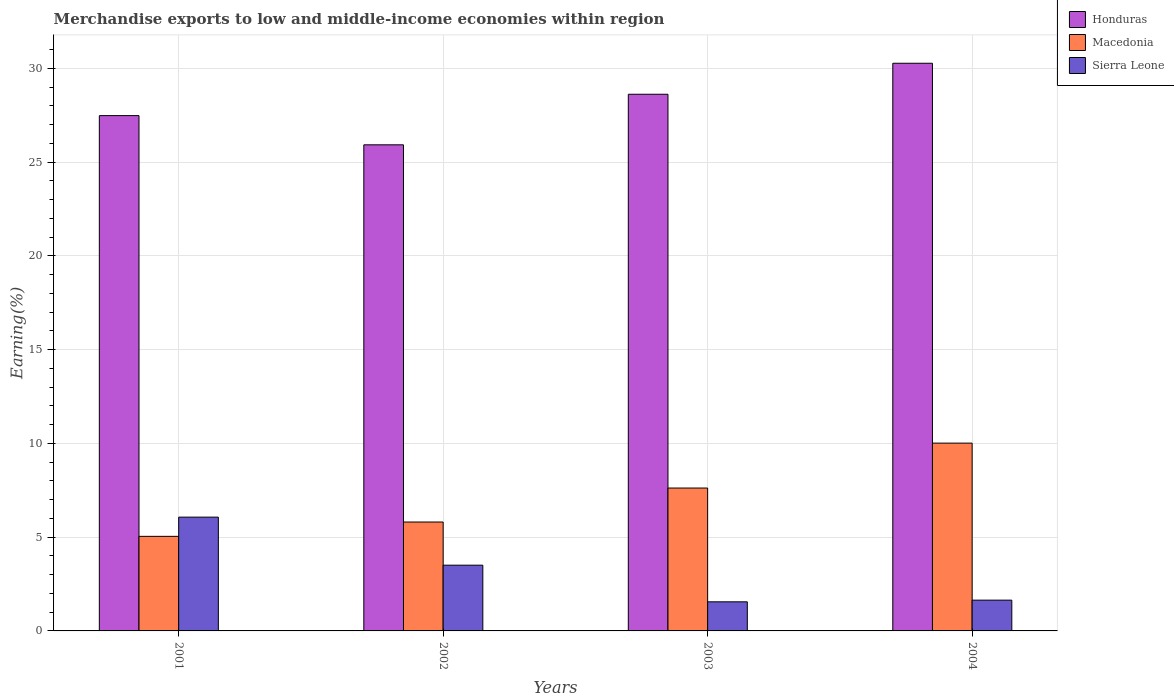How many groups of bars are there?
Provide a short and direct response. 4. Are the number of bars on each tick of the X-axis equal?
Your answer should be compact. Yes. How many bars are there on the 4th tick from the right?
Provide a short and direct response. 3. What is the label of the 3rd group of bars from the left?
Your response must be concise. 2003. In how many cases, is the number of bars for a given year not equal to the number of legend labels?
Offer a very short reply. 0. What is the percentage of amount earned from merchandise exports in Honduras in 2001?
Provide a succinct answer. 27.48. Across all years, what is the maximum percentage of amount earned from merchandise exports in Sierra Leone?
Provide a succinct answer. 6.07. Across all years, what is the minimum percentage of amount earned from merchandise exports in Sierra Leone?
Offer a terse response. 1.55. What is the total percentage of amount earned from merchandise exports in Sierra Leone in the graph?
Your answer should be very brief. 12.77. What is the difference between the percentage of amount earned from merchandise exports in Honduras in 2001 and that in 2002?
Offer a terse response. 1.56. What is the difference between the percentage of amount earned from merchandise exports in Honduras in 2001 and the percentage of amount earned from merchandise exports in Macedonia in 2002?
Make the answer very short. 21.67. What is the average percentage of amount earned from merchandise exports in Macedonia per year?
Give a very brief answer. 7.12. In the year 2004, what is the difference between the percentage of amount earned from merchandise exports in Honduras and percentage of amount earned from merchandise exports in Sierra Leone?
Offer a very short reply. 28.63. What is the ratio of the percentage of amount earned from merchandise exports in Macedonia in 2001 to that in 2004?
Provide a succinct answer. 0.5. Is the percentage of amount earned from merchandise exports in Honduras in 2001 less than that in 2004?
Offer a terse response. Yes. What is the difference between the highest and the second highest percentage of amount earned from merchandise exports in Sierra Leone?
Ensure brevity in your answer.  2.56. What is the difference between the highest and the lowest percentage of amount earned from merchandise exports in Macedonia?
Your answer should be compact. 4.97. In how many years, is the percentage of amount earned from merchandise exports in Sierra Leone greater than the average percentage of amount earned from merchandise exports in Sierra Leone taken over all years?
Your response must be concise. 2. What does the 1st bar from the left in 2003 represents?
Keep it short and to the point. Honduras. What does the 1st bar from the right in 2003 represents?
Give a very brief answer. Sierra Leone. Are all the bars in the graph horizontal?
Offer a very short reply. No. How many years are there in the graph?
Your answer should be compact. 4. Are the values on the major ticks of Y-axis written in scientific E-notation?
Provide a succinct answer. No. Where does the legend appear in the graph?
Your response must be concise. Top right. How many legend labels are there?
Your response must be concise. 3. What is the title of the graph?
Make the answer very short. Merchandise exports to low and middle-income economies within region. What is the label or title of the Y-axis?
Keep it short and to the point. Earning(%). What is the Earning(%) in Honduras in 2001?
Provide a succinct answer. 27.48. What is the Earning(%) in Macedonia in 2001?
Ensure brevity in your answer.  5.04. What is the Earning(%) of Sierra Leone in 2001?
Make the answer very short. 6.07. What is the Earning(%) of Honduras in 2002?
Your answer should be very brief. 25.92. What is the Earning(%) of Macedonia in 2002?
Offer a terse response. 5.81. What is the Earning(%) of Sierra Leone in 2002?
Provide a short and direct response. 3.51. What is the Earning(%) of Honduras in 2003?
Offer a terse response. 28.62. What is the Earning(%) of Macedonia in 2003?
Your answer should be compact. 7.62. What is the Earning(%) of Sierra Leone in 2003?
Offer a terse response. 1.55. What is the Earning(%) in Honduras in 2004?
Your response must be concise. 30.27. What is the Earning(%) of Macedonia in 2004?
Your answer should be very brief. 10.01. What is the Earning(%) in Sierra Leone in 2004?
Provide a short and direct response. 1.64. Across all years, what is the maximum Earning(%) of Honduras?
Keep it short and to the point. 30.27. Across all years, what is the maximum Earning(%) of Macedonia?
Offer a very short reply. 10.01. Across all years, what is the maximum Earning(%) of Sierra Leone?
Your response must be concise. 6.07. Across all years, what is the minimum Earning(%) of Honduras?
Provide a succinct answer. 25.92. Across all years, what is the minimum Earning(%) in Macedonia?
Offer a very short reply. 5.04. Across all years, what is the minimum Earning(%) in Sierra Leone?
Offer a terse response. 1.55. What is the total Earning(%) in Honduras in the graph?
Offer a very short reply. 112.28. What is the total Earning(%) of Macedonia in the graph?
Offer a very short reply. 28.48. What is the total Earning(%) in Sierra Leone in the graph?
Your answer should be compact. 12.77. What is the difference between the Earning(%) of Honduras in 2001 and that in 2002?
Your response must be concise. 1.56. What is the difference between the Earning(%) in Macedonia in 2001 and that in 2002?
Make the answer very short. -0.76. What is the difference between the Earning(%) of Sierra Leone in 2001 and that in 2002?
Keep it short and to the point. 2.56. What is the difference between the Earning(%) in Honduras in 2001 and that in 2003?
Your response must be concise. -1.14. What is the difference between the Earning(%) of Macedonia in 2001 and that in 2003?
Your response must be concise. -2.58. What is the difference between the Earning(%) in Sierra Leone in 2001 and that in 2003?
Your answer should be compact. 4.52. What is the difference between the Earning(%) of Honduras in 2001 and that in 2004?
Provide a short and direct response. -2.79. What is the difference between the Earning(%) of Macedonia in 2001 and that in 2004?
Provide a short and direct response. -4.97. What is the difference between the Earning(%) in Sierra Leone in 2001 and that in 2004?
Offer a very short reply. 4.43. What is the difference between the Earning(%) of Honduras in 2002 and that in 2003?
Your answer should be very brief. -2.7. What is the difference between the Earning(%) in Macedonia in 2002 and that in 2003?
Give a very brief answer. -1.81. What is the difference between the Earning(%) in Sierra Leone in 2002 and that in 2003?
Make the answer very short. 1.95. What is the difference between the Earning(%) in Honduras in 2002 and that in 2004?
Your answer should be very brief. -4.35. What is the difference between the Earning(%) of Macedonia in 2002 and that in 2004?
Your answer should be very brief. -4.21. What is the difference between the Earning(%) in Sierra Leone in 2002 and that in 2004?
Your answer should be compact. 1.86. What is the difference between the Earning(%) in Honduras in 2003 and that in 2004?
Your answer should be compact. -1.65. What is the difference between the Earning(%) in Macedonia in 2003 and that in 2004?
Provide a short and direct response. -2.4. What is the difference between the Earning(%) in Sierra Leone in 2003 and that in 2004?
Provide a succinct answer. -0.09. What is the difference between the Earning(%) in Honduras in 2001 and the Earning(%) in Macedonia in 2002?
Your answer should be compact. 21.67. What is the difference between the Earning(%) in Honduras in 2001 and the Earning(%) in Sierra Leone in 2002?
Provide a short and direct response. 23.97. What is the difference between the Earning(%) in Macedonia in 2001 and the Earning(%) in Sierra Leone in 2002?
Your response must be concise. 1.54. What is the difference between the Earning(%) in Honduras in 2001 and the Earning(%) in Macedonia in 2003?
Make the answer very short. 19.86. What is the difference between the Earning(%) of Honduras in 2001 and the Earning(%) of Sierra Leone in 2003?
Offer a terse response. 25.93. What is the difference between the Earning(%) in Macedonia in 2001 and the Earning(%) in Sierra Leone in 2003?
Provide a succinct answer. 3.49. What is the difference between the Earning(%) of Honduras in 2001 and the Earning(%) of Macedonia in 2004?
Make the answer very short. 17.46. What is the difference between the Earning(%) in Honduras in 2001 and the Earning(%) in Sierra Leone in 2004?
Offer a terse response. 25.84. What is the difference between the Earning(%) of Macedonia in 2001 and the Earning(%) of Sierra Leone in 2004?
Make the answer very short. 3.4. What is the difference between the Earning(%) of Honduras in 2002 and the Earning(%) of Macedonia in 2003?
Ensure brevity in your answer.  18.3. What is the difference between the Earning(%) of Honduras in 2002 and the Earning(%) of Sierra Leone in 2003?
Keep it short and to the point. 24.37. What is the difference between the Earning(%) in Macedonia in 2002 and the Earning(%) in Sierra Leone in 2003?
Give a very brief answer. 4.26. What is the difference between the Earning(%) of Honduras in 2002 and the Earning(%) of Macedonia in 2004?
Your answer should be compact. 15.91. What is the difference between the Earning(%) in Honduras in 2002 and the Earning(%) in Sierra Leone in 2004?
Provide a succinct answer. 24.28. What is the difference between the Earning(%) of Macedonia in 2002 and the Earning(%) of Sierra Leone in 2004?
Your answer should be compact. 4.17. What is the difference between the Earning(%) in Honduras in 2003 and the Earning(%) in Macedonia in 2004?
Provide a succinct answer. 18.6. What is the difference between the Earning(%) in Honduras in 2003 and the Earning(%) in Sierra Leone in 2004?
Keep it short and to the point. 26.97. What is the difference between the Earning(%) in Macedonia in 2003 and the Earning(%) in Sierra Leone in 2004?
Give a very brief answer. 5.98. What is the average Earning(%) in Honduras per year?
Your response must be concise. 28.07. What is the average Earning(%) in Macedonia per year?
Provide a succinct answer. 7.12. What is the average Earning(%) in Sierra Leone per year?
Make the answer very short. 3.19. In the year 2001, what is the difference between the Earning(%) of Honduras and Earning(%) of Macedonia?
Make the answer very short. 22.43. In the year 2001, what is the difference between the Earning(%) in Honduras and Earning(%) in Sierra Leone?
Keep it short and to the point. 21.41. In the year 2001, what is the difference between the Earning(%) in Macedonia and Earning(%) in Sierra Leone?
Your answer should be compact. -1.03. In the year 2002, what is the difference between the Earning(%) in Honduras and Earning(%) in Macedonia?
Your answer should be very brief. 20.11. In the year 2002, what is the difference between the Earning(%) in Honduras and Earning(%) in Sierra Leone?
Your response must be concise. 22.41. In the year 2002, what is the difference between the Earning(%) of Macedonia and Earning(%) of Sierra Leone?
Your response must be concise. 2.3. In the year 2003, what is the difference between the Earning(%) of Honduras and Earning(%) of Macedonia?
Your response must be concise. 21. In the year 2003, what is the difference between the Earning(%) in Honduras and Earning(%) in Sierra Leone?
Offer a very short reply. 27.06. In the year 2003, what is the difference between the Earning(%) of Macedonia and Earning(%) of Sierra Leone?
Keep it short and to the point. 6.07. In the year 2004, what is the difference between the Earning(%) in Honduras and Earning(%) in Macedonia?
Offer a terse response. 20.25. In the year 2004, what is the difference between the Earning(%) in Honduras and Earning(%) in Sierra Leone?
Keep it short and to the point. 28.63. In the year 2004, what is the difference between the Earning(%) in Macedonia and Earning(%) in Sierra Leone?
Keep it short and to the point. 8.37. What is the ratio of the Earning(%) in Honduras in 2001 to that in 2002?
Make the answer very short. 1.06. What is the ratio of the Earning(%) of Macedonia in 2001 to that in 2002?
Offer a terse response. 0.87. What is the ratio of the Earning(%) in Sierra Leone in 2001 to that in 2002?
Your response must be concise. 1.73. What is the ratio of the Earning(%) in Honduras in 2001 to that in 2003?
Your answer should be very brief. 0.96. What is the ratio of the Earning(%) of Macedonia in 2001 to that in 2003?
Keep it short and to the point. 0.66. What is the ratio of the Earning(%) in Sierra Leone in 2001 to that in 2003?
Your answer should be compact. 3.91. What is the ratio of the Earning(%) in Honduras in 2001 to that in 2004?
Provide a succinct answer. 0.91. What is the ratio of the Earning(%) of Macedonia in 2001 to that in 2004?
Keep it short and to the point. 0.5. What is the ratio of the Earning(%) in Sierra Leone in 2001 to that in 2004?
Ensure brevity in your answer.  3.7. What is the ratio of the Earning(%) in Honduras in 2002 to that in 2003?
Offer a very short reply. 0.91. What is the ratio of the Earning(%) in Macedonia in 2002 to that in 2003?
Make the answer very short. 0.76. What is the ratio of the Earning(%) in Sierra Leone in 2002 to that in 2003?
Provide a short and direct response. 2.26. What is the ratio of the Earning(%) in Honduras in 2002 to that in 2004?
Provide a short and direct response. 0.86. What is the ratio of the Earning(%) in Macedonia in 2002 to that in 2004?
Offer a terse response. 0.58. What is the ratio of the Earning(%) in Sierra Leone in 2002 to that in 2004?
Ensure brevity in your answer.  2.14. What is the ratio of the Earning(%) in Honduras in 2003 to that in 2004?
Provide a short and direct response. 0.95. What is the ratio of the Earning(%) in Macedonia in 2003 to that in 2004?
Keep it short and to the point. 0.76. What is the ratio of the Earning(%) of Sierra Leone in 2003 to that in 2004?
Your response must be concise. 0.95. What is the difference between the highest and the second highest Earning(%) of Honduras?
Provide a short and direct response. 1.65. What is the difference between the highest and the second highest Earning(%) of Macedonia?
Make the answer very short. 2.4. What is the difference between the highest and the second highest Earning(%) of Sierra Leone?
Your response must be concise. 2.56. What is the difference between the highest and the lowest Earning(%) of Honduras?
Ensure brevity in your answer.  4.35. What is the difference between the highest and the lowest Earning(%) in Macedonia?
Offer a very short reply. 4.97. What is the difference between the highest and the lowest Earning(%) in Sierra Leone?
Your response must be concise. 4.52. 